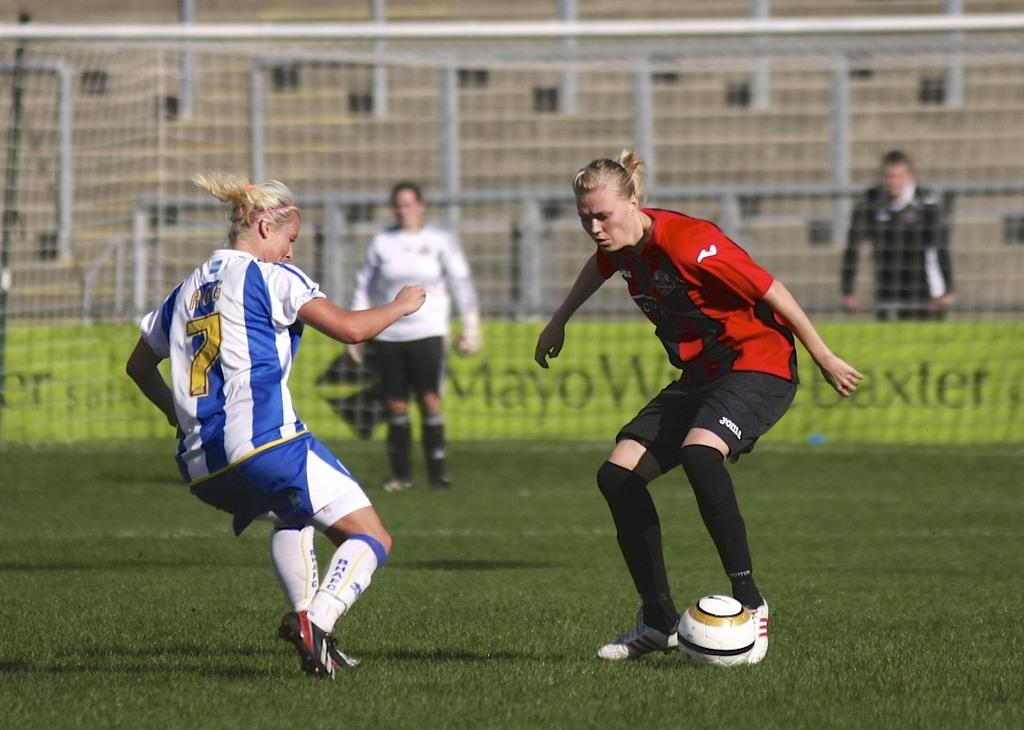What can be seen in the image that separates or encloses an area? There is a fence in the image. How many people are present in the image? There are four people in the image. What are two of the people doing in the image? Two of the people are playing with a football. What type of knife is being used by one of the people in the image? There is no knife present in the image; the people are playing with a football. What is the wish of the person standing on the left side of the image? There is no indication of a wish or any person standing on the left side of the image in the provided facts. 